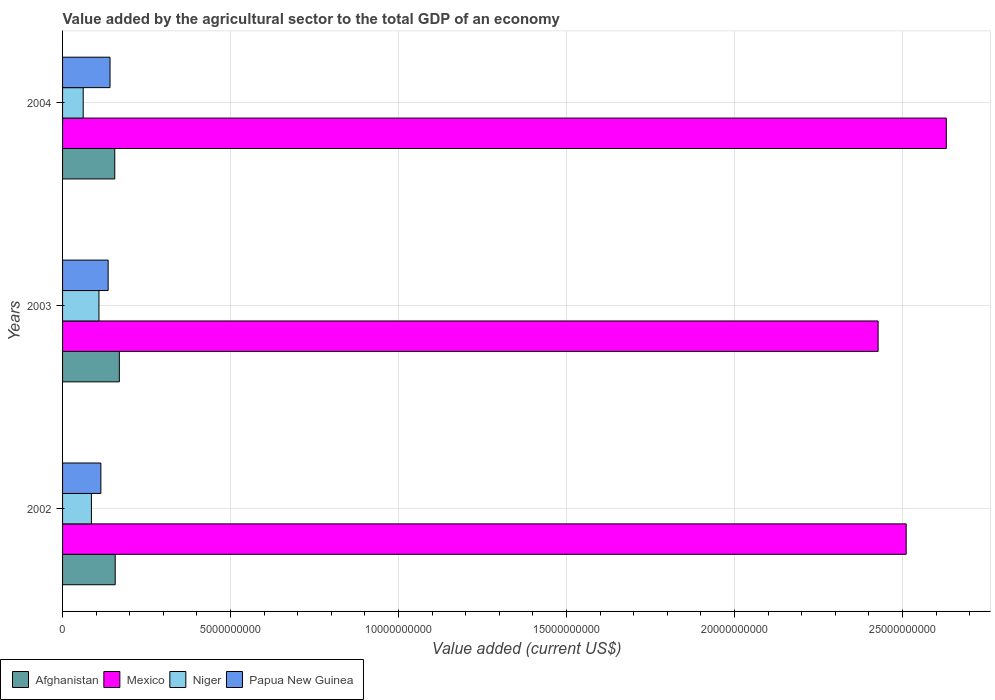How many different coloured bars are there?
Your answer should be compact. 4. How many groups of bars are there?
Provide a short and direct response. 3. Are the number of bars per tick equal to the number of legend labels?
Keep it short and to the point. Yes. What is the label of the 3rd group of bars from the top?
Make the answer very short. 2002. In how many cases, is the number of bars for a given year not equal to the number of legend labels?
Your answer should be very brief. 0. What is the value added by the agricultural sector to the total GDP in Niger in 2002?
Your answer should be very brief. 8.59e+08. Across all years, what is the maximum value added by the agricultural sector to the total GDP in Mexico?
Provide a short and direct response. 2.63e+1. Across all years, what is the minimum value added by the agricultural sector to the total GDP in Papua New Guinea?
Your answer should be compact. 1.14e+09. In which year was the value added by the agricultural sector to the total GDP in Mexico maximum?
Provide a short and direct response. 2004. In which year was the value added by the agricultural sector to the total GDP in Niger minimum?
Provide a short and direct response. 2004. What is the total value added by the agricultural sector to the total GDP in Afghanistan in the graph?
Offer a terse response. 4.81e+09. What is the difference between the value added by the agricultural sector to the total GDP in Mexico in 2002 and that in 2003?
Offer a terse response. 8.36e+08. What is the difference between the value added by the agricultural sector to the total GDP in Niger in 2003 and the value added by the agricultural sector to the total GDP in Afghanistan in 2002?
Keep it short and to the point. -4.83e+08. What is the average value added by the agricultural sector to the total GDP in Papua New Guinea per year?
Offer a terse response. 1.30e+09. In the year 2004, what is the difference between the value added by the agricultural sector to the total GDP in Afghanistan and value added by the agricultural sector to the total GDP in Mexico?
Provide a short and direct response. -2.47e+1. What is the ratio of the value added by the agricultural sector to the total GDP in Afghanistan in 2003 to that in 2004?
Offer a very short reply. 1.09. Is the difference between the value added by the agricultural sector to the total GDP in Afghanistan in 2003 and 2004 greater than the difference between the value added by the agricultural sector to the total GDP in Mexico in 2003 and 2004?
Your answer should be compact. Yes. What is the difference between the highest and the second highest value added by the agricultural sector to the total GDP in Niger?
Your answer should be very brief. 2.24e+08. What is the difference between the highest and the lowest value added by the agricultural sector to the total GDP in Mexico?
Ensure brevity in your answer.  2.03e+09. Is the sum of the value added by the agricultural sector to the total GDP in Papua New Guinea in 2003 and 2004 greater than the maximum value added by the agricultural sector to the total GDP in Afghanistan across all years?
Offer a very short reply. Yes. Is it the case that in every year, the sum of the value added by the agricultural sector to the total GDP in Papua New Guinea and value added by the agricultural sector to the total GDP in Afghanistan is greater than the sum of value added by the agricultural sector to the total GDP in Niger and value added by the agricultural sector to the total GDP in Mexico?
Offer a very short reply. No. What does the 4th bar from the top in 2004 represents?
Provide a succinct answer. Afghanistan. What does the 4th bar from the bottom in 2002 represents?
Make the answer very short. Papua New Guinea. What is the difference between two consecutive major ticks on the X-axis?
Your answer should be compact. 5.00e+09. Are the values on the major ticks of X-axis written in scientific E-notation?
Provide a short and direct response. No. What is the title of the graph?
Give a very brief answer. Value added by the agricultural sector to the total GDP of an economy. What is the label or title of the X-axis?
Your response must be concise. Value added (current US$). What is the label or title of the Y-axis?
Give a very brief answer. Years. What is the Value added (current US$) in Afghanistan in 2002?
Ensure brevity in your answer.  1.57e+09. What is the Value added (current US$) in Mexico in 2002?
Make the answer very short. 2.51e+1. What is the Value added (current US$) in Niger in 2002?
Offer a very short reply. 8.59e+08. What is the Value added (current US$) of Papua New Guinea in 2002?
Provide a succinct answer. 1.14e+09. What is the Value added (current US$) of Afghanistan in 2003?
Give a very brief answer. 1.69e+09. What is the Value added (current US$) in Mexico in 2003?
Make the answer very short. 2.43e+1. What is the Value added (current US$) in Niger in 2003?
Offer a very short reply. 1.08e+09. What is the Value added (current US$) in Papua New Guinea in 2003?
Provide a short and direct response. 1.36e+09. What is the Value added (current US$) of Afghanistan in 2004?
Ensure brevity in your answer.  1.55e+09. What is the Value added (current US$) in Mexico in 2004?
Keep it short and to the point. 2.63e+1. What is the Value added (current US$) in Niger in 2004?
Ensure brevity in your answer.  6.14e+08. What is the Value added (current US$) in Papua New Guinea in 2004?
Offer a terse response. 1.41e+09. Across all years, what is the maximum Value added (current US$) in Afghanistan?
Your answer should be compact. 1.69e+09. Across all years, what is the maximum Value added (current US$) in Mexico?
Ensure brevity in your answer.  2.63e+1. Across all years, what is the maximum Value added (current US$) of Niger?
Give a very brief answer. 1.08e+09. Across all years, what is the maximum Value added (current US$) of Papua New Guinea?
Provide a short and direct response. 1.41e+09. Across all years, what is the minimum Value added (current US$) of Afghanistan?
Your response must be concise. 1.55e+09. Across all years, what is the minimum Value added (current US$) of Mexico?
Your response must be concise. 2.43e+1. Across all years, what is the minimum Value added (current US$) in Niger?
Offer a terse response. 6.14e+08. Across all years, what is the minimum Value added (current US$) of Papua New Guinea?
Your response must be concise. 1.14e+09. What is the total Value added (current US$) of Afghanistan in the graph?
Your answer should be very brief. 4.81e+09. What is the total Value added (current US$) of Mexico in the graph?
Offer a terse response. 7.57e+1. What is the total Value added (current US$) in Niger in the graph?
Keep it short and to the point. 2.56e+09. What is the total Value added (current US$) in Papua New Guinea in the graph?
Provide a short and direct response. 3.91e+09. What is the difference between the Value added (current US$) of Afghanistan in 2002 and that in 2003?
Offer a terse response. -1.23e+08. What is the difference between the Value added (current US$) in Mexico in 2002 and that in 2003?
Ensure brevity in your answer.  8.36e+08. What is the difference between the Value added (current US$) in Niger in 2002 and that in 2003?
Offer a very short reply. -2.24e+08. What is the difference between the Value added (current US$) of Papua New Guinea in 2002 and that in 2003?
Ensure brevity in your answer.  -2.17e+08. What is the difference between the Value added (current US$) in Afghanistan in 2002 and that in 2004?
Your response must be concise. 1.30e+07. What is the difference between the Value added (current US$) of Mexico in 2002 and that in 2004?
Provide a succinct answer. -1.19e+09. What is the difference between the Value added (current US$) in Niger in 2002 and that in 2004?
Keep it short and to the point. 2.45e+08. What is the difference between the Value added (current US$) of Papua New Guinea in 2002 and that in 2004?
Provide a short and direct response. -2.73e+08. What is the difference between the Value added (current US$) in Afghanistan in 2003 and that in 2004?
Make the answer very short. 1.36e+08. What is the difference between the Value added (current US$) of Mexico in 2003 and that in 2004?
Your answer should be compact. -2.03e+09. What is the difference between the Value added (current US$) of Niger in 2003 and that in 2004?
Make the answer very short. 4.69e+08. What is the difference between the Value added (current US$) in Papua New Guinea in 2003 and that in 2004?
Ensure brevity in your answer.  -5.63e+07. What is the difference between the Value added (current US$) in Afghanistan in 2002 and the Value added (current US$) in Mexico in 2003?
Keep it short and to the point. -2.27e+1. What is the difference between the Value added (current US$) in Afghanistan in 2002 and the Value added (current US$) in Niger in 2003?
Your answer should be compact. 4.83e+08. What is the difference between the Value added (current US$) in Afghanistan in 2002 and the Value added (current US$) in Papua New Guinea in 2003?
Ensure brevity in your answer.  2.10e+08. What is the difference between the Value added (current US$) in Mexico in 2002 and the Value added (current US$) in Niger in 2003?
Keep it short and to the point. 2.40e+1. What is the difference between the Value added (current US$) in Mexico in 2002 and the Value added (current US$) in Papua New Guinea in 2003?
Offer a very short reply. 2.38e+1. What is the difference between the Value added (current US$) of Niger in 2002 and the Value added (current US$) of Papua New Guinea in 2003?
Keep it short and to the point. -4.97e+08. What is the difference between the Value added (current US$) in Afghanistan in 2002 and the Value added (current US$) in Mexico in 2004?
Your answer should be compact. -2.47e+1. What is the difference between the Value added (current US$) in Afghanistan in 2002 and the Value added (current US$) in Niger in 2004?
Provide a short and direct response. 9.52e+08. What is the difference between the Value added (current US$) of Afghanistan in 2002 and the Value added (current US$) of Papua New Guinea in 2004?
Offer a very short reply. 1.54e+08. What is the difference between the Value added (current US$) of Mexico in 2002 and the Value added (current US$) of Niger in 2004?
Ensure brevity in your answer.  2.45e+1. What is the difference between the Value added (current US$) of Mexico in 2002 and the Value added (current US$) of Papua New Guinea in 2004?
Offer a very short reply. 2.37e+1. What is the difference between the Value added (current US$) of Niger in 2002 and the Value added (current US$) of Papua New Guinea in 2004?
Your response must be concise. -5.54e+08. What is the difference between the Value added (current US$) in Afghanistan in 2003 and the Value added (current US$) in Mexico in 2004?
Offer a terse response. -2.46e+1. What is the difference between the Value added (current US$) in Afghanistan in 2003 and the Value added (current US$) in Niger in 2004?
Offer a very short reply. 1.08e+09. What is the difference between the Value added (current US$) in Afghanistan in 2003 and the Value added (current US$) in Papua New Guinea in 2004?
Offer a terse response. 2.77e+08. What is the difference between the Value added (current US$) in Mexico in 2003 and the Value added (current US$) in Niger in 2004?
Provide a short and direct response. 2.37e+1. What is the difference between the Value added (current US$) in Mexico in 2003 and the Value added (current US$) in Papua New Guinea in 2004?
Offer a very short reply. 2.29e+1. What is the difference between the Value added (current US$) of Niger in 2003 and the Value added (current US$) of Papua New Guinea in 2004?
Offer a terse response. -3.30e+08. What is the average Value added (current US$) in Afghanistan per year?
Ensure brevity in your answer.  1.60e+09. What is the average Value added (current US$) of Mexico per year?
Make the answer very short. 2.52e+1. What is the average Value added (current US$) of Niger per year?
Make the answer very short. 8.52e+08. What is the average Value added (current US$) in Papua New Guinea per year?
Make the answer very short. 1.30e+09. In the year 2002, what is the difference between the Value added (current US$) in Afghanistan and Value added (current US$) in Mexico?
Provide a succinct answer. -2.35e+1. In the year 2002, what is the difference between the Value added (current US$) in Afghanistan and Value added (current US$) in Niger?
Ensure brevity in your answer.  7.08e+08. In the year 2002, what is the difference between the Value added (current US$) in Afghanistan and Value added (current US$) in Papua New Guinea?
Ensure brevity in your answer.  4.27e+08. In the year 2002, what is the difference between the Value added (current US$) in Mexico and Value added (current US$) in Niger?
Your answer should be very brief. 2.42e+1. In the year 2002, what is the difference between the Value added (current US$) of Mexico and Value added (current US$) of Papua New Guinea?
Provide a short and direct response. 2.40e+1. In the year 2002, what is the difference between the Value added (current US$) of Niger and Value added (current US$) of Papua New Guinea?
Your answer should be very brief. -2.81e+08. In the year 2003, what is the difference between the Value added (current US$) in Afghanistan and Value added (current US$) in Mexico?
Your answer should be very brief. -2.26e+1. In the year 2003, what is the difference between the Value added (current US$) in Afghanistan and Value added (current US$) in Niger?
Your answer should be compact. 6.07e+08. In the year 2003, what is the difference between the Value added (current US$) in Afghanistan and Value added (current US$) in Papua New Guinea?
Offer a very short reply. 3.33e+08. In the year 2003, what is the difference between the Value added (current US$) in Mexico and Value added (current US$) in Niger?
Give a very brief answer. 2.32e+1. In the year 2003, what is the difference between the Value added (current US$) in Mexico and Value added (current US$) in Papua New Guinea?
Provide a succinct answer. 2.29e+1. In the year 2003, what is the difference between the Value added (current US$) in Niger and Value added (current US$) in Papua New Guinea?
Your answer should be compact. -2.73e+08. In the year 2004, what is the difference between the Value added (current US$) of Afghanistan and Value added (current US$) of Mexico?
Keep it short and to the point. -2.47e+1. In the year 2004, what is the difference between the Value added (current US$) of Afghanistan and Value added (current US$) of Niger?
Ensure brevity in your answer.  9.39e+08. In the year 2004, what is the difference between the Value added (current US$) of Afghanistan and Value added (current US$) of Papua New Guinea?
Provide a short and direct response. 1.41e+08. In the year 2004, what is the difference between the Value added (current US$) in Mexico and Value added (current US$) in Niger?
Offer a very short reply. 2.57e+1. In the year 2004, what is the difference between the Value added (current US$) of Mexico and Value added (current US$) of Papua New Guinea?
Ensure brevity in your answer.  2.49e+1. In the year 2004, what is the difference between the Value added (current US$) of Niger and Value added (current US$) of Papua New Guinea?
Your answer should be very brief. -7.98e+08. What is the ratio of the Value added (current US$) of Afghanistan in 2002 to that in 2003?
Keep it short and to the point. 0.93. What is the ratio of the Value added (current US$) of Mexico in 2002 to that in 2003?
Offer a very short reply. 1.03. What is the ratio of the Value added (current US$) of Niger in 2002 to that in 2003?
Keep it short and to the point. 0.79. What is the ratio of the Value added (current US$) of Papua New Guinea in 2002 to that in 2003?
Offer a very short reply. 0.84. What is the ratio of the Value added (current US$) in Afghanistan in 2002 to that in 2004?
Make the answer very short. 1.01. What is the ratio of the Value added (current US$) in Mexico in 2002 to that in 2004?
Ensure brevity in your answer.  0.95. What is the ratio of the Value added (current US$) of Niger in 2002 to that in 2004?
Your answer should be very brief. 1.4. What is the ratio of the Value added (current US$) in Papua New Guinea in 2002 to that in 2004?
Keep it short and to the point. 0.81. What is the ratio of the Value added (current US$) of Afghanistan in 2003 to that in 2004?
Keep it short and to the point. 1.09. What is the ratio of the Value added (current US$) in Mexico in 2003 to that in 2004?
Your response must be concise. 0.92. What is the ratio of the Value added (current US$) in Niger in 2003 to that in 2004?
Keep it short and to the point. 1.76. What is the ratio of the Value added (current US$) in Papua New Guinea in 2003 to that in 2004?
Ensure brevity in your answer.  0.96. What is the difference between the highest and the second highest Value added (current US$) of Afghanistan?
Offer a terse response. 1.23e+08. What is the difference between the highest and the second highest Value added (current US$) of Mexico?
Keep it short and to the point. 1.19e+09. What is the difference between the highest and the second highest Value added (current US$) in Niger?
Your answer should be compact. 2.24e+08. What is the difference between the highest and the second highest Value added (current US$) of Papua New Guinea?
Keep it short and to the point. 5.63e+07. What is the difference between the highest and the lowest Value added (current US$) of Afghanistan?
Ensure brevity in your answer.  1.36e+08. What is the difference between the highest and the lowest Value added (current US$) of Mexico?
Provide a short and direct response. 2.03e+09. What is the difference between the highest and the lowest Value added (current US$) in Niger?
Ensure brevity in your answer.  4.69e+08. What is the difference between the highest and the lowest Value added (current US$) in Papua New Guinea?
Provide a short and direct response. 2.73e+08. 